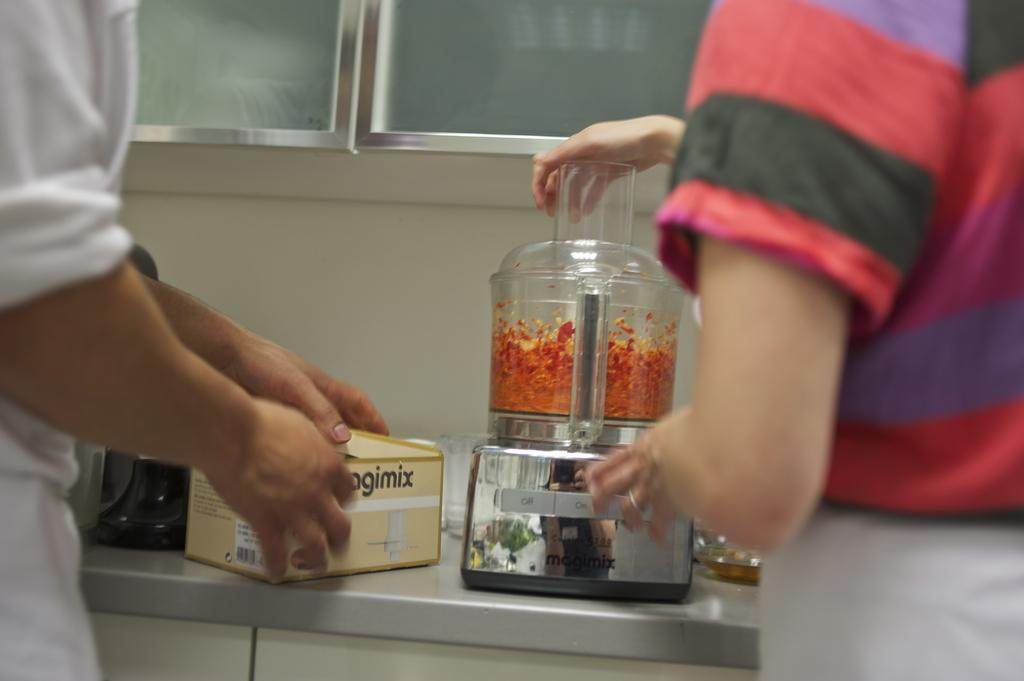Provide a one-sentence caption for the provided image. Two people stand at a counter, one is using a food processor while the other has the box with the partial word "agimix" seen on it. 